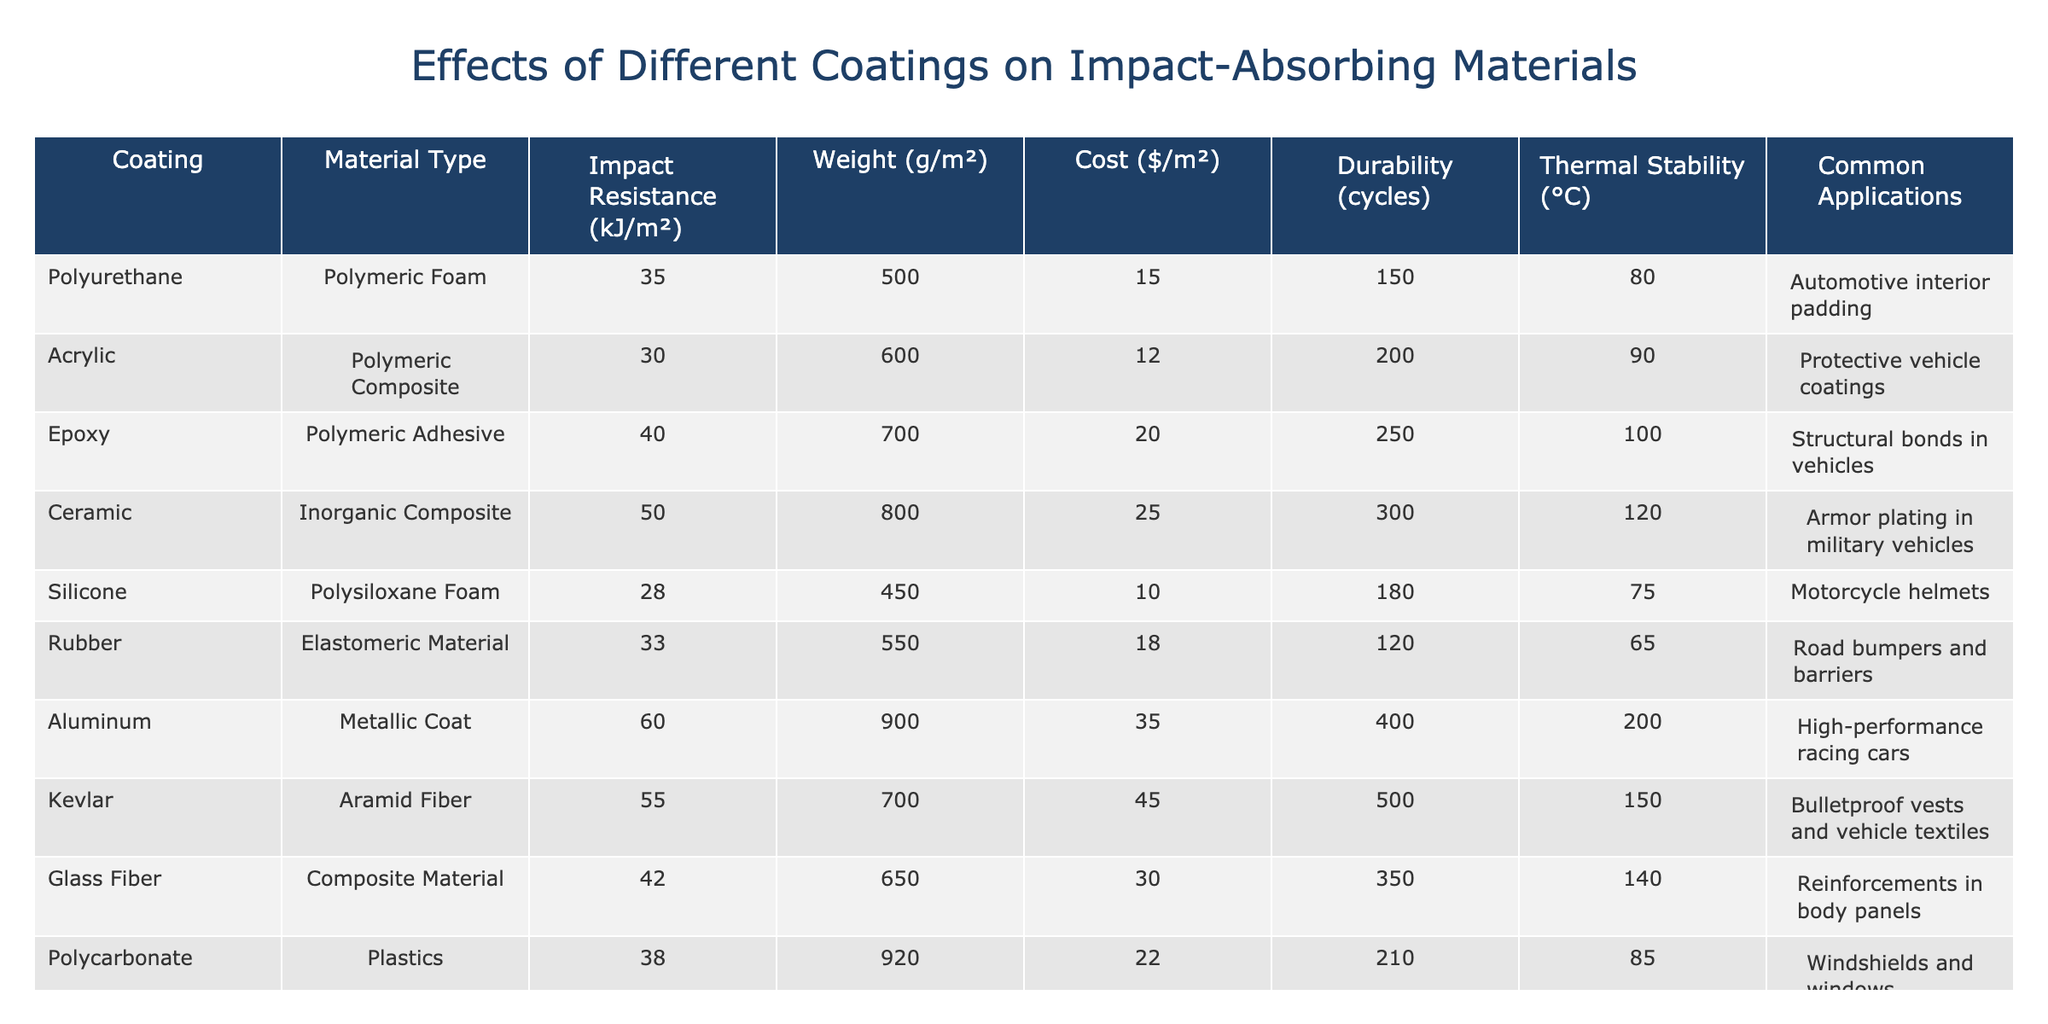What is the impact resistance of the ceramic coating? The impact resistance is listed in the table under the column 'Impact Resistance (kJ/m²)' for the ceramic coating. The value is 50 kJ/m².
Answer: 50 kJ/m² Which coating has the highest thermal stability? To find the highest thermal stability, I look at the 'Thermal Stability (°C)' column and identify the maximum value. The aluminum coating has the highest thermal stability at 200 °C.
Answer: 200 °C What is the average cost of all coatings? To calculate the average cost, I first sum the costs of all coatings: 15 + 12 + 20 + 25 + 10 + 18 + 35 + 45 + 30 + 22 =  287. Since there are 10 coatings, I divide by 10 to find the average. 287 / 10 = 28.7.
Answer: 28.7 Is the impact resistance of polyurethane higher than that of silicone? To answer, I compare the 'Impact Resistance (kJ/m²)' values. Polyurethane has 35 kJ/m² and silicone has 28 kJ/m². Since 35 is greater than 28, the statement is true.
Answer: Yes Which coating has the lowest weight per square meter? By examining the 'Weight (g/m²)' column, I find the minimum value. The silicone coating has the lowest weight at 450 g/m².
Answer: 450 g/m² What is the difference in durability between aluminum and ceramic coatings? I look at the 'Durability (cycles)' column for both coatings. Aluminum has 400 cycles, and ceramic has 300 cycles. The difference is 400 - 300 = 100 cycles.
Answer: 100 cycles Does the acrylic coating have a higher impact resistance than rubber? I compare their impact resistances: acrylic has 30 kJ/m², and rubber has 33 kJ/m². Since 30 is less than 33, the statement is false.
Answer: No Which coating is commonly used for automotive interior padding? Checking the 'Common Applications' column for the relevant coating, polyurethane is noted as used for automotive interior padding.
Answer: Polyurethane What is the total impact resistance of Kevlar and glass fiber coatings combined? I sum their impact resistances: Kevlar has 55 kJ/m², and glass fiber has 42 kJ/m². The total is 55 + 42 = 97 kJ/m².
Answer: 97 kJ/m² 